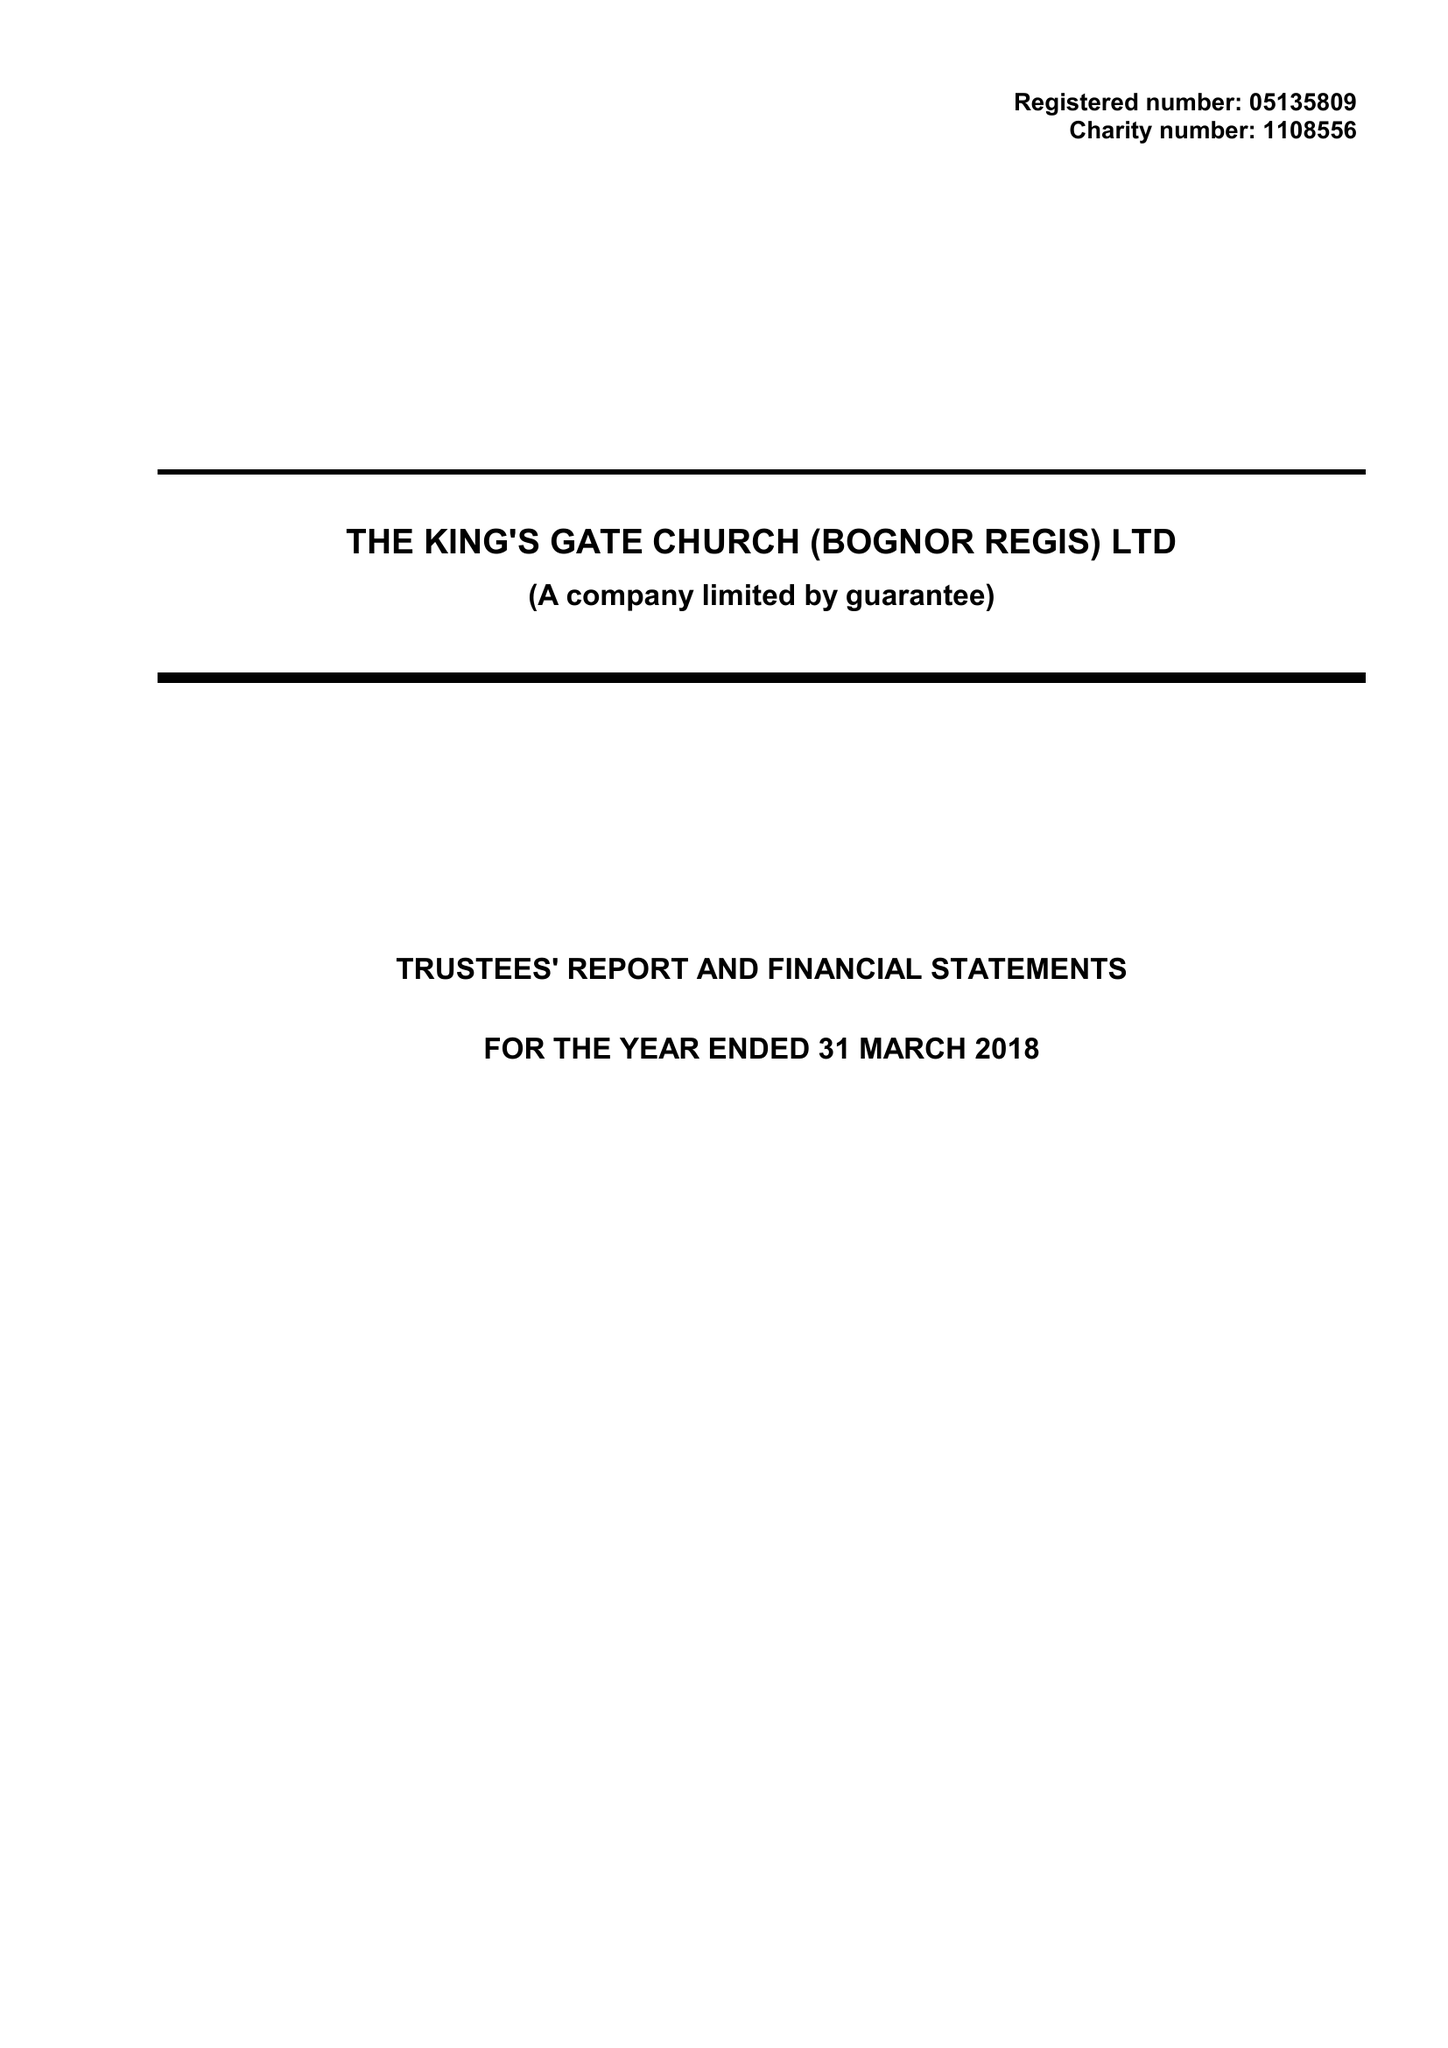What is the value for the income_annually_in_british_pounds?
Answer the question using a single word or phrase. 42681.00 